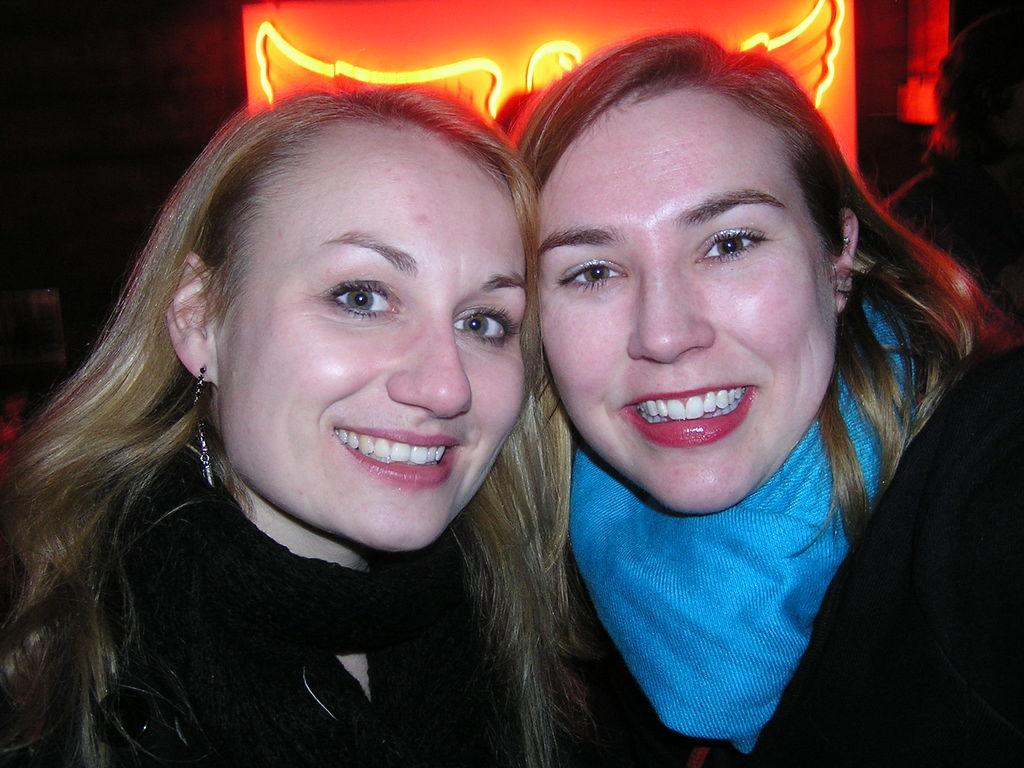How many people are in the image? There are two persons in the image. What are the persons doing in the image? The persons are smiling. What can be seen in the background of the image? There is a light board in the background of the image. What type of bird can be seen flying in the image? There is no bird present in the image; it only features two persons and a light board in the background. 